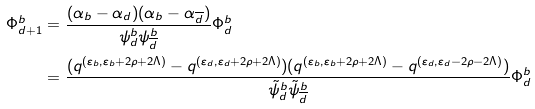Convert formula to latex. <formula><loc_0><loc_0><loc_500><loc_500>\Phi ^ { b } _ { d + 1 } & = \frac { ( \alpha _ { b } - \alpha _ { d } ) ( \alpha _ { b } - \alpha _ { \overline { d } } ) } { \psi ^ { b } _ { d } \psi ^ { b } _ { \overline { d } } } \Phi ^ { b } _ { d } \\ & = \frac { ( q ^ { ( \varepsilon _ { b } , \varepsilon _ { b } + 2 \rho + 2 \Lambda ) } - q ^ { ( \varepsilon _ { d } , \varepsilon _ { d } + 2 \rho + 2 \Lambda ) } ) ( q ^ { ( \varepsilon _ { b } , \varepsilon _ { b } + 2 \rho + 2 \Lambda ) } - q ^ { ( \varepsilon _ { d } , \varepsilon _ { d } - 2 \rho - 2 \Lambda ) } ) } { \tilde { \psi } ^ { b } _ { d } \tilde { \psi } ^ { b } _ { \overline { d } } } \Phi ^ { b } _ { d }</formula> 